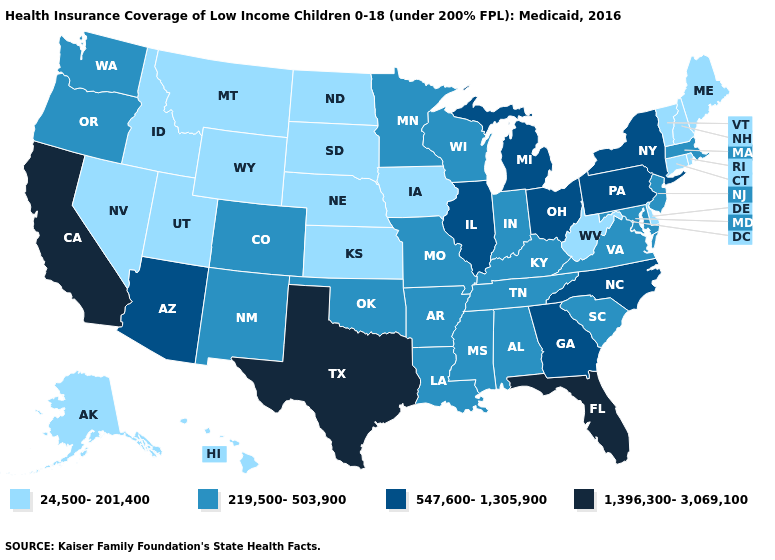What is the value of Wyoming?
Quick response, please. 24,500-201,400. Name the states that have a value in the range 24,500-201,400?
Write a very short answer. Alaska, Connecticut, Delaware, Hawaii, Idaho, Iowa, Kansas, Maine, Montana, Nebraska, Nevada, New Hampshire, North Dakota, Rhode Island, South Dakota, Utah, Vermont, West Virginia, Wyoming. Does Tennessee have the lowest value in the USA?
Short answer required. No. Does Tennessee have the same value as Ohio?
Answer briefly. No. Among the states that border Colorado , does Kansas have the highest value?
Write a very short answer. No. Name the states that have a value in the range 24,500-201,400?
Write a very short answer. Alaska, Connecticut, Delaware, Hawaii, Idaho, Iowa, Kansas, Maine, Montana, Nebraska, Nevada, New Hampshire, North Dakota, Rhode Island, South Dakota, Utah, Vermont, West Virginia, Wyoming. Does Michigan have the same value as Mississippi?
Be succinct. No. Among the states that border Alabama , does Florida have the highest value?
Keep it brief. Yes. What is the value of Kansas?
Be succinct. 24,500-201,400. Name the states that have a value in the range 24,500-201,400?
Be succinct. Alaska, Connecticut, Delaware, Hawaii, Idaho, Iowa, Kansas, Maine, Montana, Nebraska, Nevada, New Hampshire, North Dakota, Rhode Island, South Dakota, Utah, Vermont, West Virginia, Wyoming. Which states have the highest value in the USA?
Quick response, please. California, Florida, Texas. Which states have the lowest value in the USA?
Concise answer only. Alaska, Connecticut, Delaware, Hawaii, Idaho, Iowa, Kansas, Maine, Montana, Nebraska, Nevada, New Hampshire, North Dakota, Rhode Island, South Dakota, Utah, Vermont, West Virginia, Wyoming. What is the highest value in states that border Oklahoma?
Quick response, please. 1,396,300-3,069,100. Does Massachusetts have the highest value in the USA?
Quick response, please. No. What is the value of Wyoming?
Short answer required. 24,500-201,400. 